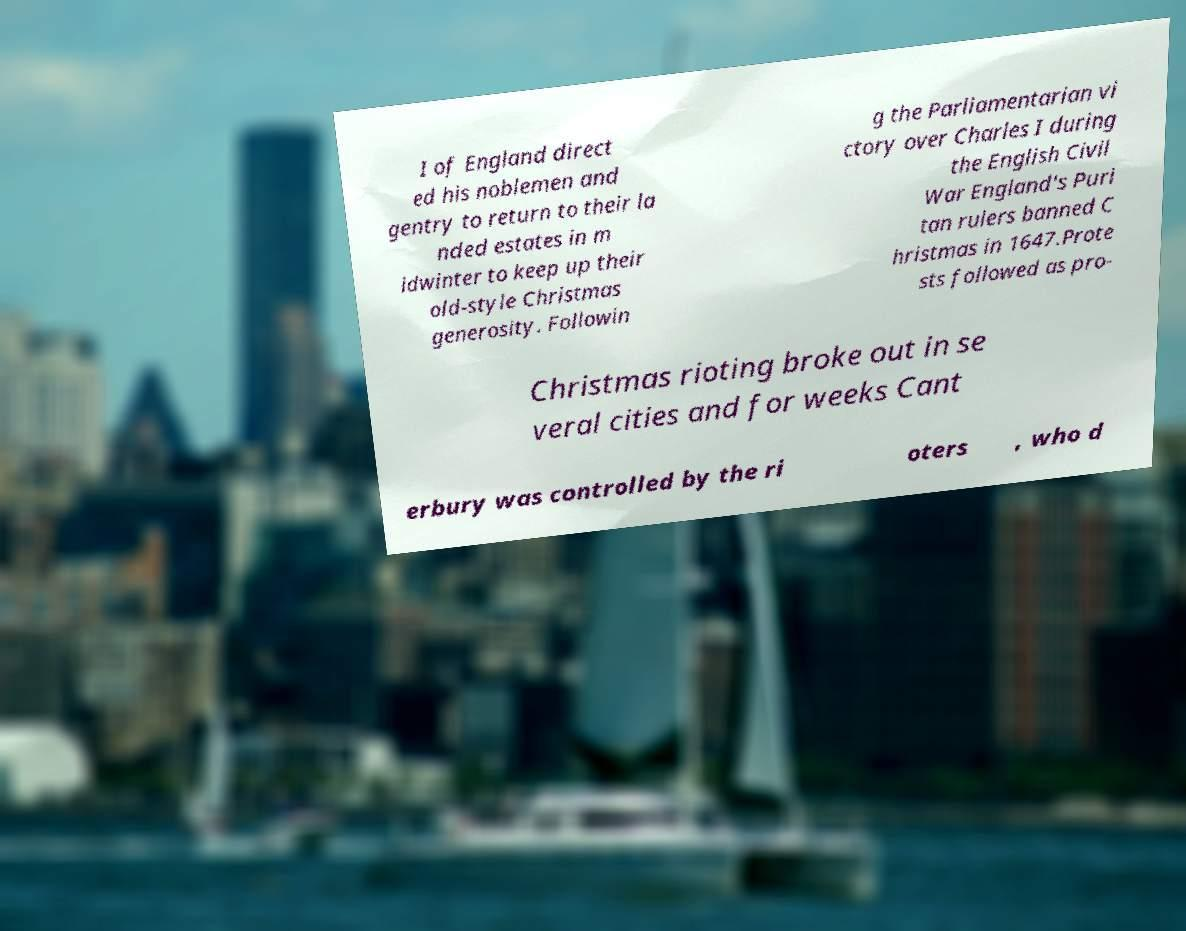Please read and relay the text visible in this image. What does it say? I of England direct ed his noblemen and gentry to return to their la nded estates in m idwinter to keep up their old-style Christmas generosity. Followin g the Parliamentarian vi ctory over Charles I during the English Civil War England's Puri tan rulers banned C hristmas in 1647.Prote sts followed as pro- Christmas rioting broke out in se veral cities and for weeks Cant erbury was controlled by the ri oters , who d 